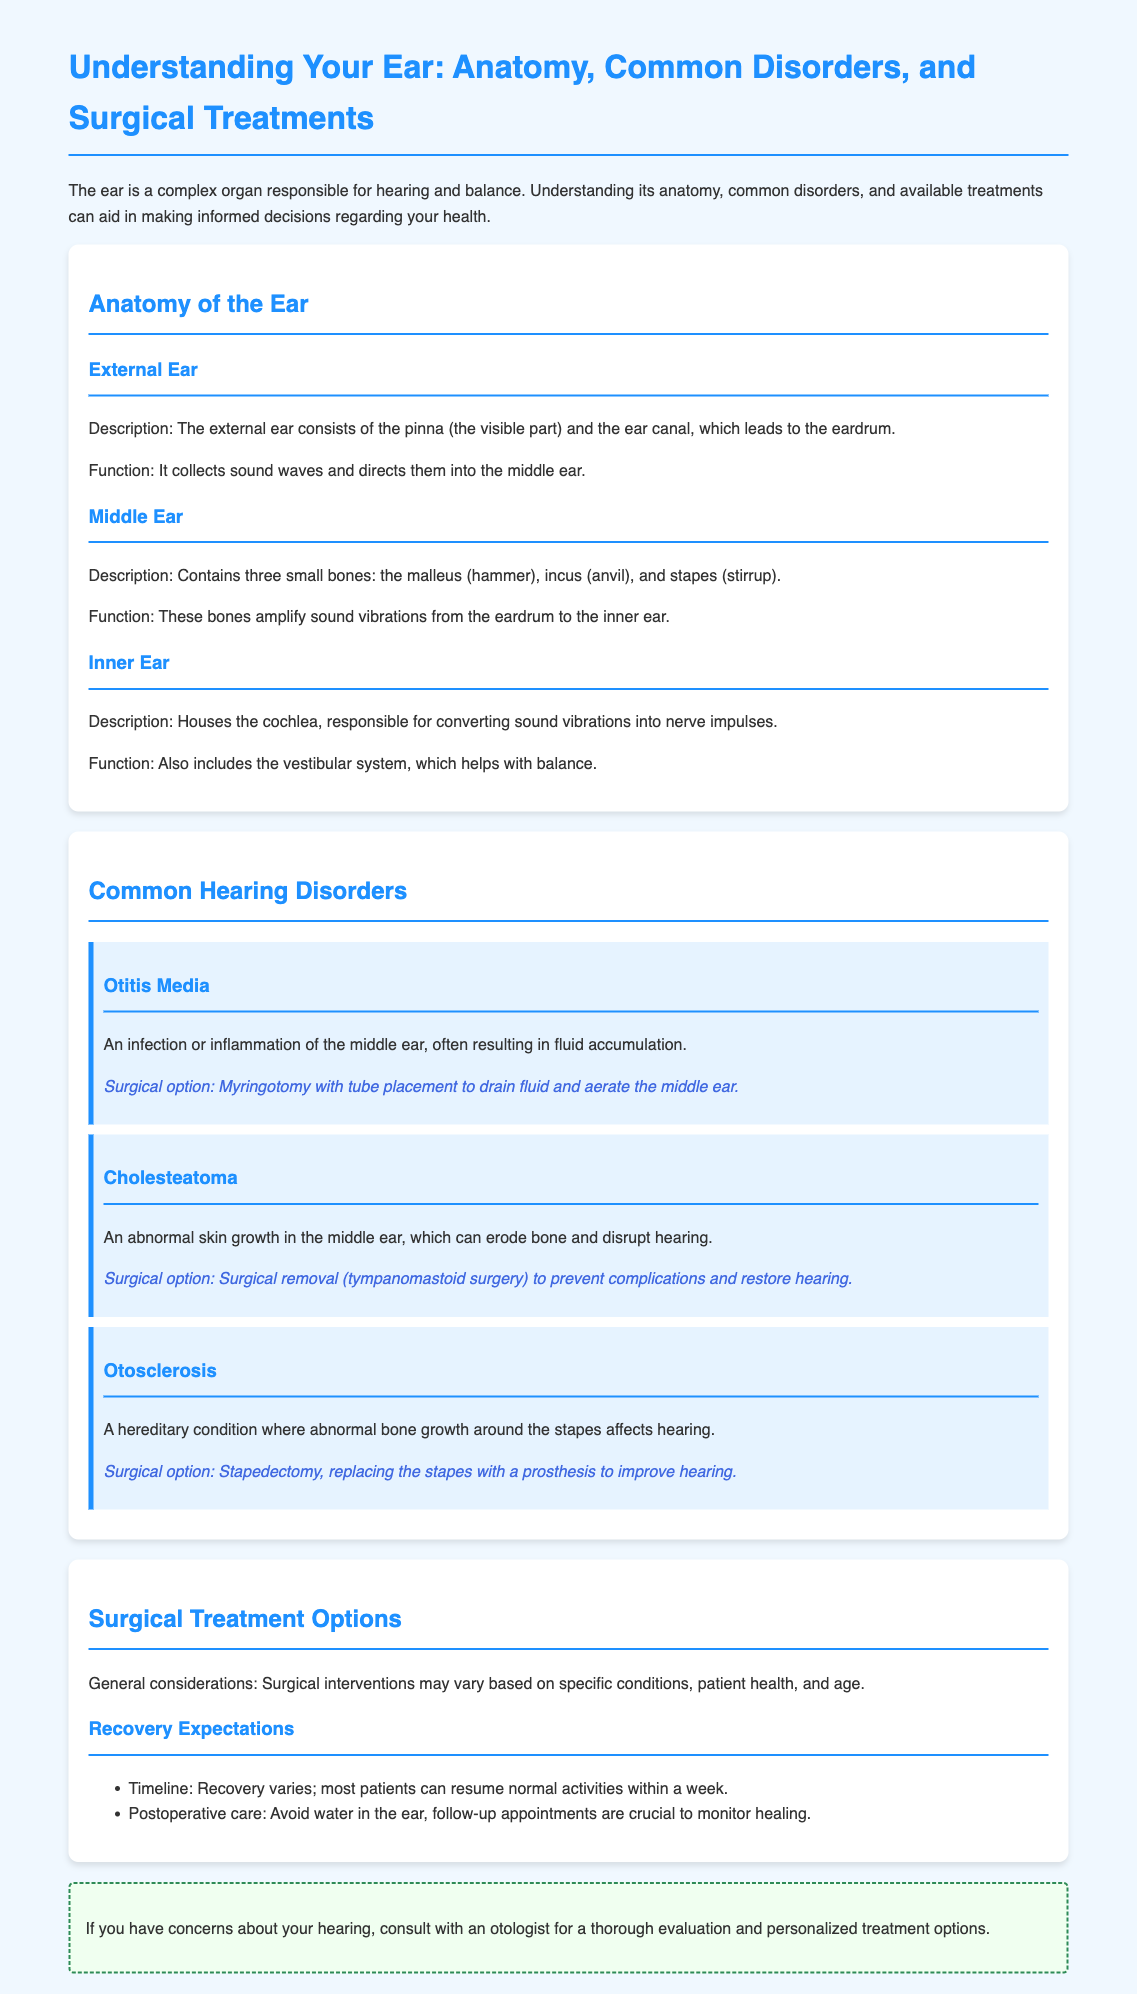What are the three parts of the ear? The three parts of the ear mentioned in the document are the external ear, middle ear, and inner ear.
Answer: external ear, middle ear, inner ear What is Otitis Media? Otitis Media is described in the document as an infection or inflammation of the middle ear, often resulting in fluid accumulation.
Answer: infection or inflammation of the middle ear What is the surgical option for Cholesteatoma? The document states that the surgical option for Cholesteatoma is tympanomastoid surgery.
Answer: tympanomastoid surgery How long does recovery generally take? The document mentions that most patients can resume normal activities within a week, indicating the recovery timeline.
Answer: within a week What function does the cochlea serve? According to the document, the cochlea is responsible for converting sound vibrations into nerve impulses.
Answer: converting sound vibrations into nerve impulses What should be avoided post-surgery? The document warns that avoiding water in the ear is crucial in postoperative care.
Answer: avoid water in the ear What condition is treated with stapedectomy? The document states that stapedectomy treats otosclerosis, which involves abnormal bone growth.
Answer: otosclerosis What type of document is this? The document is an educational brochure designed for patients regarding the ear's anatomy and related hearing disorders.
Answer: educational brochure 